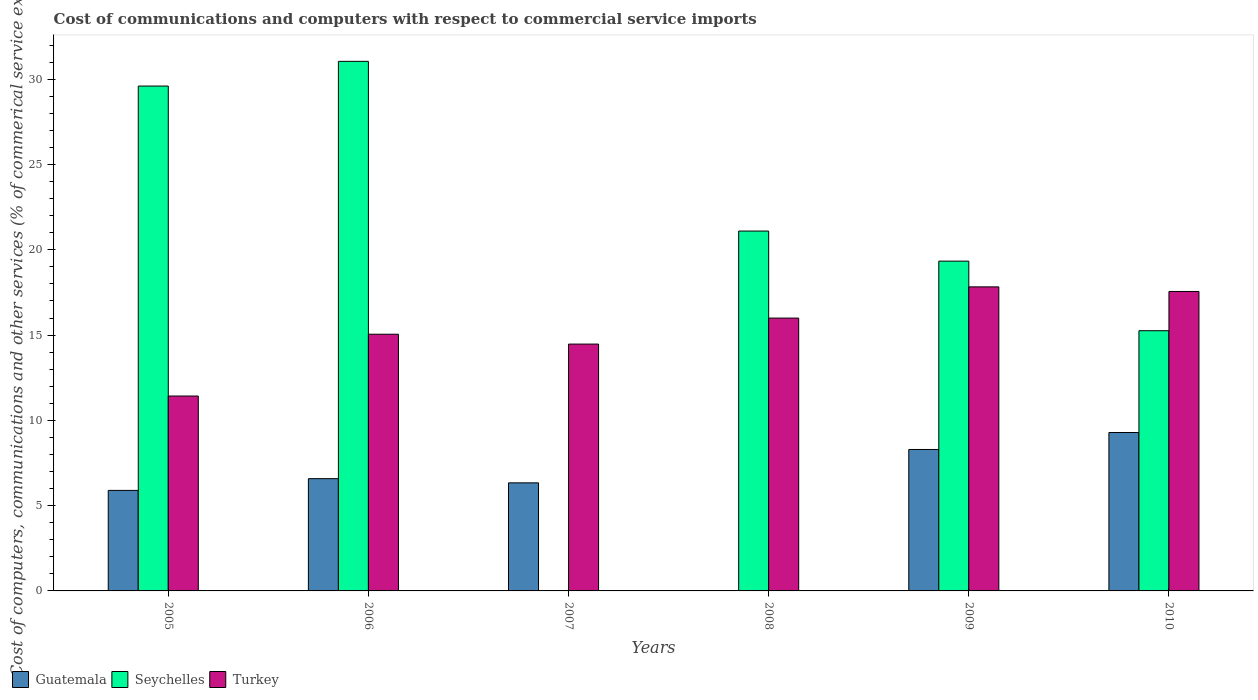How many different coloured bars are there?
Provide a succinct answer. 3. How many groups of bars are there?
Your response must be concise. 6. Are the number of bars per tick equal to the number of legend labels?
Your answer should be very brief. No. How many bars are there on the 4th tick from the left?
Offer a very short reply. 2. How many bars are there on the 1st tick from the right?
Your answer should be very brief. 3. What is the label of the 6th group of bars from the left?
Keep it short and to the point. 2010. In how many cases, is the number of bars for a given year not equal to the number of legend labels?
Offer a very short reply. 2. What is the cost of communications and computers in Turkey in 2009?
Ensure brevity in your answer.  17.83. Across all years, what is the maximum cost of communications and computers in Turkey?
Offer a terse response. 17.83. In which year was the cost of communications and computers in Seychelles maximum?
Keep it short and to the point. 2006. What is the total cost of communications and computers in Guatemala in the graph?
Your response must be concise. 36.39. What is the difference between the cost of communications and computers in Turkey in 2005 and that in 2007?
Ensure brevity in your answer.  -3.05. What is the difference between the cost of communications and computers in Guatemala in 2008 and the cost of communications and computers in Turkey in 2010?
Give a very brief answer. -17.56. What is the average cost of communications and computers in Seychelles per year?
Provide a succinct answer. 19.39. In the year 2010, what is the difference between the cost of communications and computers in Guatemala and cost of communications and computers in Seychelles?
Your answer should be compact. -5.97. What is the ratio of the cost of communications and computers in Turkey in 2008 to that in 2010?
Your answer should be compact. 0.91. Is the cost of communications and computers in Turkey in 2008 less than that in 2009?
Give a very brief answer. Yes. Is the difference between the cost of communications and computers in Guatemala in 2006 and 2010 greater than the difference between the cost of communications and computers in Seychelles in 2006 and 2010?
Provide a short and direct response. No. What is the difference between the highest and the second highest cost of communications and computers in Guatemala?
Provide a short and direct response. 1. What is the difference between the highest and the lowest cost of communications and computers in Turkey?
Ensure brevity in your answer.  6.4. In how many years, is the cost of communications and computers in Seychelles greater than the average cost of communications and computers in Seychelles taken over all years?
Offer a terse response. 3. How many years are there in the graph?
Your answer should be very brief. 6. Are the values on the major ticks of Y-axis written in scientific E-notation?
Offer a very short reply. No. Does the graph contain any zero values?
Give a very brief answer. Yes. What is the title of the graph?
Give a very brief answer. Cost of communications and computers with respect to commercial service imports. Does "Congo (Republic)" appear as one of the legend labels in the graph?
Ensure brevity in your answer.  No. What is the label or title of the X-axis?
Offer a very short reply. Years. What is the label or title of the Y-axis?
Make the answer very short. Cost of computers, communications and other services (% of commerical service exports). What is the Cost of computers, communications and other services (% of commerical service exports) in Guatemala in 2005?
Your answer should be compact. 5.89. What is the Cost of computers, communications and other services (% of commerical service exports) in Seychelles in 2005?
Make the answer very short. 29.6. What is the Cost of computers, communications and other services (% of commerical service exports) in Turkey in 2005?
Ensure brevity in your answer.  11.43. What is the Cost of computers, communications and other services (% of commerical service exports) in Guatemala in 2006?
Give a very brief answer. 6.58. What is the Cost of computers, communications and other services (% of commerical service exports) in Seychelles in 2006?
Give a very brief answer. 31.05. What is the Cost of computers, communications and other services (% of commerical service exports) of Turkey in 2006?
Give a very brief answer. 15.05. What is the Cost of computers, communications and other services (% of commerical service exports) of Guatemala in 2007?
Give a very brief answer. 6.34. What is the Cost of computers, communications and other services (% of commerical service exports) in Turkey in 2007?
Give a very brief answer. 14.47. What is the Cost of computers, communications and other services (% of commerical service exports) of Guatemala in 2008?
Keep it short and to the point. 0. What is the Cost of computers, communications and other services (% of commerical service exports) of Seychelles in 2008?
Offer a very short reply. 21.1. What is the Cost of computers, communications and other services (% of commerical service exports) in Turkey in 2008?
Give a very brief answer. 16. What is the Cost of computers, communications and other services (% of commerical service exports) of Guatemala in 2009?
Provide a succinct answer. 8.29. What is the Cost of computers, communications and other services (% of commerical service exports) of Seychelles in 2009?
Ensure brevity in your answer.  19.34. What is the Cost of computers, communications and other services (% of commerical service exports) in Turkey in 2009?
Your answer should be very brief. 17.83. What is the Cost of computers, communications and other services (% of commerical service exports) of Guatemala in 2010?
Your answer should be compact. 9.29. What is the Cost of computers, communications and other services (% of commerical service exports) of Seychelles in 2010?
Offer a terse response. 15.26. What is the Cost of computers, communications and other services (% of commerical service exports) in Turkey in 2010?
Offer a very short reply. 17.56. Across all years, what is the maximum Cost of computers, communications and other services (% of commerical service exports) in Guatemala?
Offer a very short reply. 9.29. Across all years, what is the maximum Cost of computers, communications and other services (% of commerical service exports) of Seychelles?
Make the answer very short. 31.05. Across all years, what is the maximum Cost of computers, communications and other services (% of commerical service exports) of Turkey?
Ensure brevity in your answer.  17.83. Across all years, what is the minimum Cost of computers, communications and other services (% of commerical service exports) in Seychelles?
Your response must be concise. 0. Across all years, what is the minimum Cost of computers, communications and other services (% of commerical service exports) in Turkey?
Give a very brief answer. 11.43. What is the total Cost of computers, communications and other services (% of commerical service exports) of Guatemala in the graph?
Keep it short and to the point. 36.39. What is the total Cost of computers, communications and other services (% of commerical service exports) of Seychelles in the graph?
Keep it short and to the point. 116.34. What is the total Cost of computers, communications and other services (% of commerical service exports) of Turkey in the graph?
Keep it short and to the point. 92.32. What is the difference between the Cost of computers, communications and other services (% of commerical service exports) of Guatemala in 2005 and that in 2006?
Keep it short and to the point. -0.69. What is the difference between the Cost of computers, communications and other services (% of commerical service exports) of Seychelles in 2005 and that in 2006?
Give a very brief answer. -1.45. What is the difference between the Cost of computers, communications and other services (% of commerical service exports) in Turkey in 2005 and that in 2006?
Ensure brevity in your answer.  -3.62. What is the difference between the Cost of computers, communications and other services (% of commerical service exports) in Guatemala in 2005 and that in 2007?
Offer a terse response. -0.44. What is the difference between the Cost of computers, communications and other services (% of commerical service exports) in Turkey in 2005 and that in 2007?
Provide a short and direct response. -3.05. What is the difference between the Cost of computers, communications and other services (% of commerical service exports) of Seychelles in 2005 and that in 2008?
Give a very brief answer. 8.5. What is the difference between the Cost of computers, communications and other services (% of commerical service exports) in Turkey in 2005 and that in 2008?
Keep it short and to the point. -4.57. What is the difference between the Cost of computers, communications and other services (% of commerical service exports) in Guatemala in 2005 and that in 2009?
Ensure brevity in your answer.  -2.4. What is the difference between the Cost of computers, communications and other services (% of commerical service exports) of Seychelles in 2005 and that in 2009?
Make the answer very short. 10.26. What is the difference between the Cost of computers, communications and other services (% of commerical service exports) of Turkey in 2005 and that in 2009?
Your answer should be compact. -6.4. What is the difference between the Cost of computers, communications and other services (% of commerical service exports) of Guatemala in 2005 and that in 2010?
Ensure brevity in your answer.  -3.39. What is the difference between the Cost of computers, communications and other services (% of commerical service exports) of Seychelles in 2005 and that in 2010?
Make the answer very short. 14.34. What is the difference between the Cost of computers, communications and other services (% of commerical service exports) of Turkey in 2005 and that in 2010?
Provide a succinct answer. -6.13. What is the difference between the Cost of computers, communications and other services (% of commerical service exports) of Guatemala in 2006 and that in 2007?
Your answer should be very brief. 0.25. What is the difference between the Cost of computers, communications and other services (% of commerical service exports) in Turkey in 2006 and that in 2007?
Offer a terse response. 0.58. What is the difference between the Cost of computers, communications and other services (% of commerical service exports) in Seychelles in 2006 and that in 2008?
Your answer should be compact. 9.95. What is the difference between the Cost of computers, communications and other services (% of commerical service exports) of Turkey in 2006 and that in 2008?
Your answer should be compact. -0.95. What is the difference between the Cost of computers, communications and other services (% of commerical service exports) in Guatemala in 2006 and that in 2009?
Your answer should be very brief. -1.71. What is the difference between the Cost of computers, communications and other services (% of commerical service exports) in Seychelles in 2006 and that in 2009?
Provide a succinct answer. 11.71. What is the difference between the Cost of computers, communications and other services (% of commerical service exports) in Turkey in 2006 and that in 2009?
Ensure brevity in your answer.  -2.78. What is the difference between the Cost of computers, communications and other services (% of commerical service exports) of Guatemala in 2006 and that in 2010?
Offer a very short reply. -2.71. What is the difference between the Cost of computers, communications and other services (% of commerical service exports) in Seychelles in 2006 and that in 2010?
Ensure brevity in your answer.  15.79. What is the difference between the Cost of computers, communications and other services (% of commerical service exports) of Turkey in 2006 and that in 2010?
Keep it short and to the point. -2.51. What is the difference between the Cost of computers, communications and other services (% of commerical service exports) in Turkey in 2007 and that in 2008?
Give a very brief answer. -1.52. What is the difference between the Cost of computers, communications and other services (% of commerical service exports) of Guatemala in 2007 and that in 2009?
Offer a very short reply. -1.96. What is the difference between the Cost of computers, communications and other services (% of commerical service exports) in Turkey in 2007 and that in 2009?
Your response must be concise. -3.35. What is the difference between the Cost of computers, communications and other services (% of commerical service exports) of Guatemala in 2007 and that in 2010?
Offer a terse response. -2.95. What is the difference between the Cost of computers, communications and other services (% of commerical service exports) in Turkey in 2007 and that in 2010?
Ensure brevity in your answer.  -3.08. What is the difference between the Cost of computers, communications and other services (% of commerical service exports) of Seychelles in 2008 and that in 2009?
Make the answer very short. 1.76. What is the difference between the Cost of computers, communications and other services (% of commerical service exports) of Turkey in 2008 and that in 2009?
Provide a succinct answer. -1.83. What is the difference between the Cost of computers, communications and other services (% of commerical service exports) of Seychelles in 2008 and that in 2010?
Your answer should be compact. 5.84. What is the difference between the Cost of computers, communications and other services (% of commerical service exports) in Turkey in 2008 and that in 2010?
Provide a succinct answer. -1.56. What is the difference between the Cost of computers, communications and other services (% of commerical service exports) in Guatemala in 2009 and that in 2010?
Keep it short and to the point. -0.99. What is the difference between the Cost of computers, communications and other services (% of commerical service exports) of Seychelles in 2009 and that in 2010?
Ensure brevity in your answer.  4.08. What is the difference between the Cost of computers, communications and other services (% of commerical service exports) of Turkey in 2009 and that in 2010?
Keep it short and to the point. 0.27. What is the difference between the Cost of computers, communications and other services (% of commerical service exports) of Guatemala in 2005 and the Cost of computers, communications and other services (% of commerical service exports) of Seychelles in 2006?
Make the answer very short. -25.15. What is the difference between the Cost of computers, communications and other services (% of commerical service exports) in Guatemala in 2005 and the Cost of computers, communications and other services (% of commerical service exports) in Turkey in 2006?
Keep it short and to the point. -9.16. What is the difference between the Cost of computers, communications and other services (% of commerical service exports) of Seychelles in 2005 and the Cost of computers, communications and other services (% of commerical service exports) of Turkey in 2006?
Your answer should be very brief. 14.55. What is the difference between the Cost of computers, communications and other services (% of commerical service exports) in Guatemala in 2005 and the Cost of computers, communications and other services (% of commerical service exports) in Turkey in 2007?
Keep it short and to the point. -8.58. What is the difference between the Cost of computers, communications and other services (% of commerical service exports) in Seychelles in 2005 and the Cost of computers, communications and other services (% of commerical service exports) in Turkey in 2007?
Keep it short and to the point. 15.13. What is the difference between the Cost of computers, communications and other services (% of commerical service exports) of Guatemala in 2005 and the Cost of computers, communications and other services (% of commerical service exports) of Seychelles in 2008?
Offer a very short reply. -15.21. What is the difference between the Cost of computers, communications and other services (% of commerical service exports) in Guatemala in 2005 and the Cost of computers, communications and other services (% of commerical service exports) in Turkey in 2008?
Offer a very short reply. -10.1. What is the difference between the Cost of computers, communications and other services (% of commerical service exports) of Seychelles in 2005 and the Cost of computers, communications and other services (% of commerical service exports) of Turkey in 2008?
Provide a succinct answer. 13.6. What is the difference between the Cost of computers, communications and other services (% of commerical service exports) of Guatemala in 2005 and the Cost of computers, communications and other services (% of commerical service exports) of Seychelles in 2009?
Make the answer very short. -13.44. What is the difference between the Cost of computers, communications and other services (% of commerical service exports) of Guatemala in 2005 and the Cost of computers, communications and other services (% of commerical service exports) of Turkey in 2009?
Give a very brief answer. -11.93. What is the difference between the Cost of computers, communications and other services (% of commerical service exports) of Seychelles in 2005 and the Cost of computers, communications and other services (% of commerical service exports) of Turkey in 2009?
Offer a terse response. 11.77. What is the difference between the Cost of computers, communications and other services (% of commerical service exports) in Guatemala in 2005 and the Cost of computers, communications and other services (% of commerical service exports) in Seychelles in 2010?
Ensure brevity in your answer.  -9.36. What is the difference between the Cost of computers, communications and other services (% of commerical service exports) in Guatemala in 2005 and the Cost of computers, communications and other services (% of commerical service exports) in Turkey in 2010?
Provide a succinct answer. -11.66. What is the difference between the Cost of computers, communications and other services (% of commerical service exports) of Seychelles in 2005 and the Cost of computers, communications and other services (% of commerical service exports) of Turkey in 2010?
Provide a succinct answer. 12.04. What is the difference between the Cost of computers, communications and other services (% of commerical service exports) of Guatemala in 2006 and the Cost of computers, communications and other services (% of commerical service exports) of Turkey in 2007?
Provide a succinct answer. -7.89. What is the difference between the Cost of computers, communications and other services (% of commerical service exports) of Seychelles in 2006 and the Cost of computers, communications and other services (% of commerical service exports) of Turkey in 2007?
Make the answer very short. 16.58. What is the difference between the Cost of computers, communications and other services (% of commerical service exports) of Guatemala in 2006 and the Cost of computers, communications and other services (% of commerical service exports) of Seychelles in 2008?
Make the answer very short. -14.52. What is the difference between the Cost of computers, communications and other services (% of commerical service exports) in Guatemala in 2006 and the Cost of computers, communications and other services (% of commerical service exports) in Turkey in 2008?
Offer a very short reply. -9.41. What is the difference between the Cost of computers, communications and other services (% of commerical service exports) in Seychelles in 2006 and the Cost of computers, communications and other services (% of commerical service exports) in Turkey in 2008?
Ensure brevity in your answer.  15.05. What is the difference between the Cost of computers, communications and other services (% of commerical service exports) in Guatemala in 2006 and the Cost of computers, communications and other services (% of commerical service exports) in Seychelles in 2009?
Offer a very short reply. -12.75. What is the difference between the Cost of computers, communications and other services (% of commerical service exports) of Guatemala in 2006 and the Cost of computers, communications and other services (% of commerical service exports) of Turkey in 2009?
Make the answer very short. -11.24. What is the difference between the Cost of computers, communications and other services (% of commerical service exports) of Seychelles in 2006 and the Cost of computers, communications and other services (% of commerical service exports) of Turkey in 2009?
Your answer should be compact. 13.22. What is the difference between the Cost of computers, communications and other services (% of commerical service exports) of Guatemala in 2006 and the Cost of computers, communications and other services (% of commerical service exports) of Seychelles in 2010?
Your answer should be very brief. -8.67. What is the difference between the Cost of computers, communications and other services (% of commerical service exports) in Guatemala in 2006 and the Cost of computers, communications and other services (% of commerical service exports) in Turkey in 2010?
Make the answer very short. -10.97. What is the difference between the Cost of computers, communications and other services (% of commerical service exports) of Seychelles in 2006 and the Cost of computers, communications and other services (% of commerical service exports) of Turkey in 2010?
Offer a terse response. 13.49. What is the difference between the Cost of computers, communications and other services (% of commerical service exports) of Guatemala in 2007 and the Cost of computers, communications and other services (% of commerical service exports) of Seychelles in 2008?
Offer a very short reply. -14.76. What is the difference between the Cost of computers, communications and other services (% of commerical service exports) of Guatemala in 2007 and the Cost of computers, communications and other services (% of commerical service exports) of Turkey in 2008?
Offer a terse response. -9.66. What is the difference between the Cost of computers, communications and other services (% of commerical service exports) of Guatemala in 2007 and the Cost of computers, communications and other services (% of commerical service exports) of Seychelles in 2009?
Keep it short and to the point. -13. What is the difference between the Cost of computers, communications and other services (% of commerical service exports) of Guatemala in 2007 and the Cost of computers, communications and other services (% of commerical service exports) of Turkey in 2009?
Give a very brief answer. -11.49. What is the difference between the Cost of computers, communications and other services (% of commerical service exports) of Guatemala in 2007 and the Cost of computers, communications and other services (% of commerical service exports) of Seychelles in 2010?
Your answer should be compact. -8.92. What is the difference between the Cost of computers, communications and other services (% of commerical service exports) of Guatemala in 2007 and the Cost of computers, communications and other services (% of commerical service exports) of Turkey in 2010?
Keep it short and to the point. -11.22. What is the difference between the Cost of computers, communications and other services (% of commerical service exports) in Seychelles in 2008 and the Cost of computers, communications and other services (% of commerical service exports) in Turkey in 2009?
Your answer should be very brief. 3.27. What is the difference between the Cost of computers, communications and other services (% of commerical service exports) in Seychelles in 2008 and the Cost of computers, communications and other services (% of commerical service exports) in Turkey in 2010?
Offer a very short reply. 3.54. What is the difference between the Cost of computers, communications and other services (% of commerical service exports) in Guatemala in 2009 and the Cost of computers, communications and other services (% of commerical service exports) in Seychelles in 2010?
Give a very brief answer. -6.96. What is the difference between the Cost of computers, communications and other services (% of commerical service exports) in Guatemala in 2009 and the Cost of computers, communications and other services (% of commerical service exports) in Turkey in 2010?
Provide a short and direct response. -9.26. What is the difference between the Cost of computers, communications and other services (% of commerical service exports) in Seychelles in 2009 and the Cost of computers, communications and other services (% of commerical service exports) in Turkey in 2010?
Provide a succinct answer. 1.78. What is the average Cost of computers, communications and other services (% of commerical service exports) of Guatemala per year?
Provide a succinct answer. 6.07. What is the average Cost of computers, communications and other services (% of commerical service exports) in Seychelles per year?
Your answer should be compact. 19.39. What is the average Cost of computers, communications and other services (% of commerical service exports) of Turkey per year?
Ensure brevity in your answer.  15.39. In the year 2005, what is the difference between the Cost of computers, communications and other services (% of commerical service exports) of Guatemala and Cost of computers, communications and other services (% of commerical service exports) of Seychelles?
Your response must be concise. -23.71. In the year 2005, what is the difference between the Cost of computers, communications and other services (% of commerical service exports) of Guatemala and Cost of computers, communications and other services (% of commerical service exports) of Turkey?
Your answer should be compact. -5.53. In the year 2005, what is the difference between the Cost of computers, communications and other services (% of commerical service exports) in Seychelles and Cost of computers, communications and other services (% of commerical service exports) in Turkey?
Provide a short and direct response. 18.17. In the year 2006, what is the difference between the Cost of computers, communications and other services (% of commerical service exports) of Guatemala and Cost of computers, communications and other services (% of commerical service exports) of Seychelles?
Provide a short and direct response. -24.47. In the year 2006, what is the difference between the Cost of computers, communications and other services (% of commerical service exports) of Guatemala and Cost of computers, communications and other services (% of commerical service exports) of Turkey?
Give a very brief answer. -8.47. In the year 2006, what is the difference between the Cost of computers, communications and other services (% of commerical service exports) of Seychelles and Cost of computers, communications and other services (% of commerical service exports) of Turkey?
Keep it short and to the point. 16. In the year 2007, what is the difference between the Cost of computers, communications and other services (% of commerical service exports) of Guatemala and Cost of computers, communications and other services (% of commerical service exports) of Turkey?
Offer a terse response. -8.14. In the year 2008, what is the difference between the Cost of computers, communications and other services (% of commerical service exports) of Seychelles and Cost of computers, communications and other services (% of commerical service exports) of Turkey?
Provide a succinct answer. 5.1. In the year 2009, what is the difference between the Cost of computers, communications and other services (% of commerical service exports) of Guatemala and Cost of computers, communications and other services (% of commerical service exports) of Seychelles?
Provide a short and direct response. -11.04. In the year 2009, what is the difference between the Cost of computers, communications and other services (% of commerical service exports) in Guatemala and Cost of computers, communications and other services (% of commerical service exports) in Turkey?
Offer a terse response. -9.53. In the year 2009, what is the difference between the Cost of computers, communications and other services (% of commerical service exports) of Seychelles and Cost of computers, communications and other services (% of commerical service exports) of Turkey?
Give a very brief answer. 1.51. In the year 2010, what is the difference between the Cost of computers, communications and other services (% of commerical service exports) of Guatemala and Cost of computers, communications and other services (% of commerical service exports) of Seychelles?
Make the answer very short. -5.97. In the year 2010, what is the difference between the Cost of computers, communications and other services (% of commerical service exports) in Guatemala and Cost of computers, communications and other services (% of commerical service exports) in Turkey?
Provide a succinct answer. -8.27. In the year 2010, what is the difference between the Cost of computers, communications and other services (% of commerical service exports) in Seychelles and Cost of computers, communications and other services (% of commerical service exports) in Turkey?
Ensure brevity in your answer.  -2.3. What is the ratio of the Cost of computers, communications and other services (% of commerical service exports) in Guatemala in 2005 to that in 2006?
Your answer should be very brief. 0.9. What is the ratio of the Cost of computers, communications and other services (% of commerical service exports) of Seychelles in 2005 to that in 2006?
Provide a succinct answer. 0.95. What is the ratio of the Cost of computers, communications and other services (% of commerical service exports) of Turkey in 2005 to that in 2006?
Keep it short and to the point. 0.76. What is the ratio of the Cost of computers, communications and other services (% of commerical service exports) in Guatemala in 2005 to that in 2007?
Your response must be concise. 0.93. What is the ratio of the Cost of computers, communications and other services (% of commerical service exports) of Turkey in 2005 to that in 2007?
Your response must be concise. 0.79. What is the ratio of the Cost of computers, communications and other services (% of commerical service exports) of Seychelles in 2005 to that in 2008?
Your answer should be compact. 1.4. What is the ratio of the Cost of computers, communications and other services (% of commerical service exports) in Guatemala in 2005 to that in 2009?
Your answer should be compact. 0.71. What is the ratio of the Cost of computers, communications and other services (% of commerical service exports) of Seychelles in 2005 to that in 2009?
Your response must be concise. 1.53. What is the ratio of the Cost of computers, communications and other services (% of commerical service exports) in Turkey in 2005 to that in 2009?
Make the answer very short. 0.64. What is the ratio of the Cost of computers, communications and other services (% of commerical service exports) in Guatemala in 2005 to that in 2010?
Provide a short and direct response. 0.63. What is the ratio of the Cost of computers, communications and other services (% of commerical service exports) of Seychelles in 2005 to that in 2010?
Keep it short and to the point. 1.94. What is the ratio of the Cost of computers, communications and other services (% of commerical service exports) of Turkey in 2005 to that in 2010?
Make the answer very short. 0.65. What is the ratio of the Cost of computers, communications and other services (% of commerical service exports) in Guatemala in 2006 to that in 2007?
Give a very brief answer. 1.04. What is the ratio of the Cost of computers, communications and other services (% of commerical service exports) in Seychelles in 2006 to that in 2008?
Your response must be concise. 1.47. What is the ratio of the Cost of computers, communications and other services (% of commerical service exports) in Turkey in 2006 to that in 2008?
Your response must be concise. 0.94. What is the ratio of the Cost of computers, communications and other services (% of commerical service exports) of Guatemala in 2006 to that in 2009?
Offer a terse response. 0.79. What is the ratio of the Cost of computers, communications and other services (% of commerical service exports) of Seychelles in 2006 to that in 2009?
Provide a succinct answer. 1.61. What is the ratio of the Cost of computers, communications and other services (% of commerical service exports) in Turkey in 2006 to that in 2009?
Your answer should be very brief. 0.84. What is the ratio of the Cost of computers, communications and other services (% of commerical service exports) of Guatemala in 2006 to that in 2010?
Give a very brief answer. 0.71. What is the ratio of the Cost of computers, communications and other services (% of commerical service exports) in Seychelles in 2006 to that in 2010?
Your response must be concise. 2.04. What is the ratio of the Cost of computers, communications and other services (% of commerical service exports) in Turkey in 2006 to that in 2010?
Your answer should be very brief. 0.86. What is the ratio of the Cost of computers, communications and other services (% of commerical service exports) of Turkey in 2007 to that in 2008?
Offer a terse response. 0.9. What is the ratio of the Cost of computers, communications and other services (% of commerical service exports) in Guatemala in 2007 to that in 2009?
Give a very brief answer. 0.76. What is the ratio of the Cost of computers, communications and other services (% of commerical service exports) in Turkey in 2007 to that in 2009?
Your answer should be very brief. 0.81. What is the ratio of the Cost of computers, communications and other services (% of commerical service exports) in Guatemala in 2007 to that in 2010?
Give a very brief answer. 0.68. What is the ratio of the Cost of computers, communications and other services (% of commerical service exports) of Turkey in 2007 to that in 2010?
Offer a terse response. 0.82. What is the ratio of the Cost of computers, communications and other services (% of commerical service exports) in Seychelles in 2008 to that in 2009?
Give a very brief answer. 1.09. What is the ratio of the Cost of computers, communications and other services (% of commerical service exports) of Turkey in 2008 to that in 2009?
Keep it short and to the point. 0.9. What is the ratio of the Cost of computers, communications and other services (% of commerical service exports) in Seychelles in 2008 to that in 2010?
Ensure brevity in your answer.  1.38. What is the ratio of the Cost of computers, communications and other services (% of commerical service exports) in Turkey in 2008 to that in 2010?
Provide a succinct answer. 0.91. What is the ratio of the Cost of computers, communications and other services (% of commerical service exports) in Guatemala in 2009 to that in 2010?
Make the answer very short. 0.89. What is the ratio of the Cost of computers, communications and other services (% of commerical service exports) of Seychelles in 2009 to that in 2010?
Your response must be concise. 1.27. What is the ratio of the Cost of computers, communications and other services (% of commerical service exports) in Turkey in 2009 to that in 2010?
Give a very brief answer. 1.02. What is the difference between the highest and the second highest Cost of computers, communications and other services (% of commerical service exports) in Seychelles?
Your answer should be very brief. 1.45. What is the difference between the highest and the second highest Cost of computers, communications and other services (% of commerical service exports) in Turkey?
Your answer should be compact. 0.27. What is the difference between the highest and the lowest Cost of computers, communications and other services (% of commerical service exports) in Guatemala?
Offer a very short reply. 9.29. What is the difference between the highest and the lowest Cost of computers, communications and other services (% of commerical service exports) in Seychelles?
Provide a succinct answer. 31.05. What is the difference between the highest and the lowest Cost of computers, communications and other services (% of commerical service exports) of Turkey?
Your answer should be very brief. 6.4. 